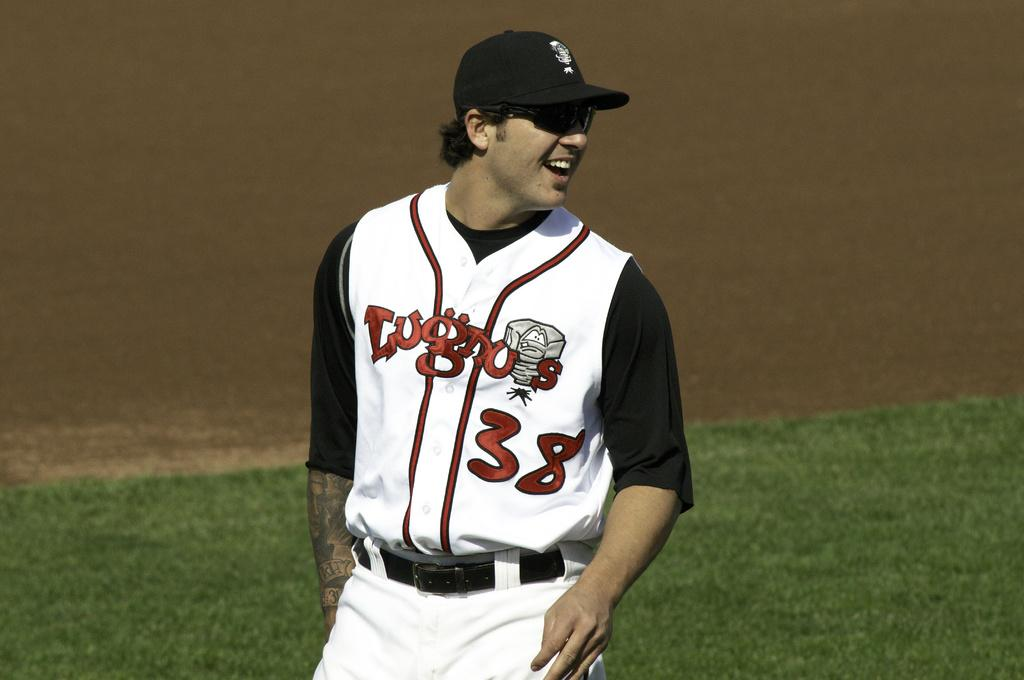<image>
Provide a brief description of the given image. A baseball player with the number 38 is smiling as he looks back on the field. 